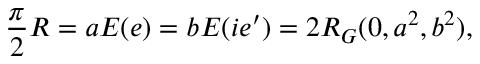<formula> <loc_0><loc_0><loc_500><loc_500>\frac { \pi } { 2 } R = a E ( e ) = b E ( i e ^ { \prime } ) = 2 R _ { G } ( 0 , a ^ { 2 } , b ^ { 2 } ) ,</formula> 